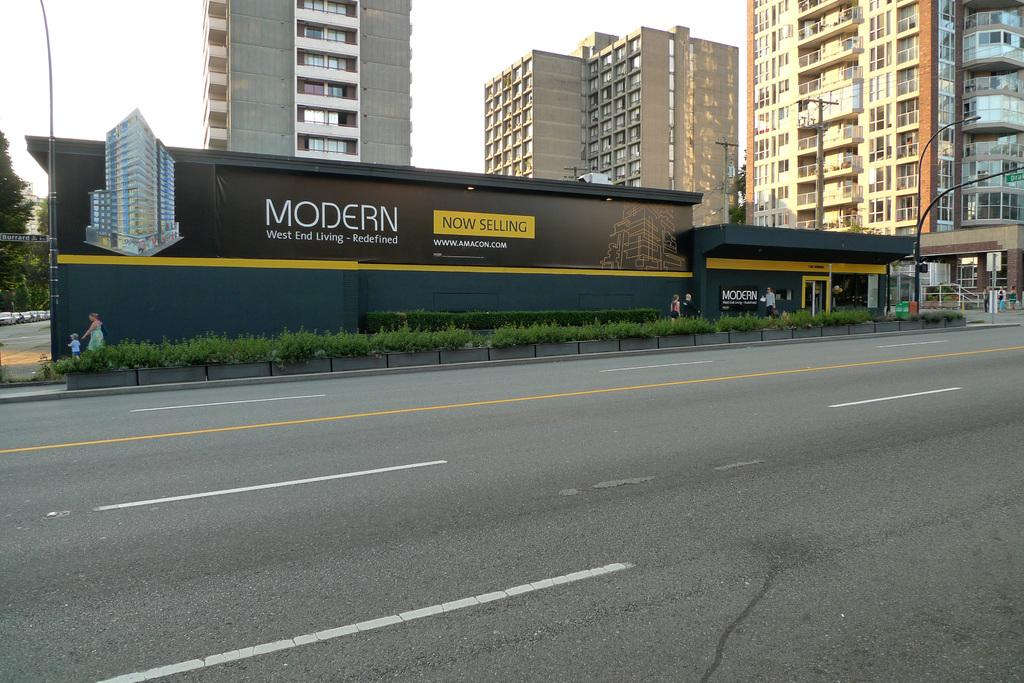What is happening in the image? There is a group of people standing in the image. What else can be seen in the image besides the people? There are vehicles on the road, plants, buildings, trees, poles, and the sky visible in the background. Can you describe the environment in the image? The image shows an urban environment with buildings, roads, and vehicles, as well as natural elements like plants, trees, and the sky. What type of cave can be seen in the image? There is no cave present in the image. 